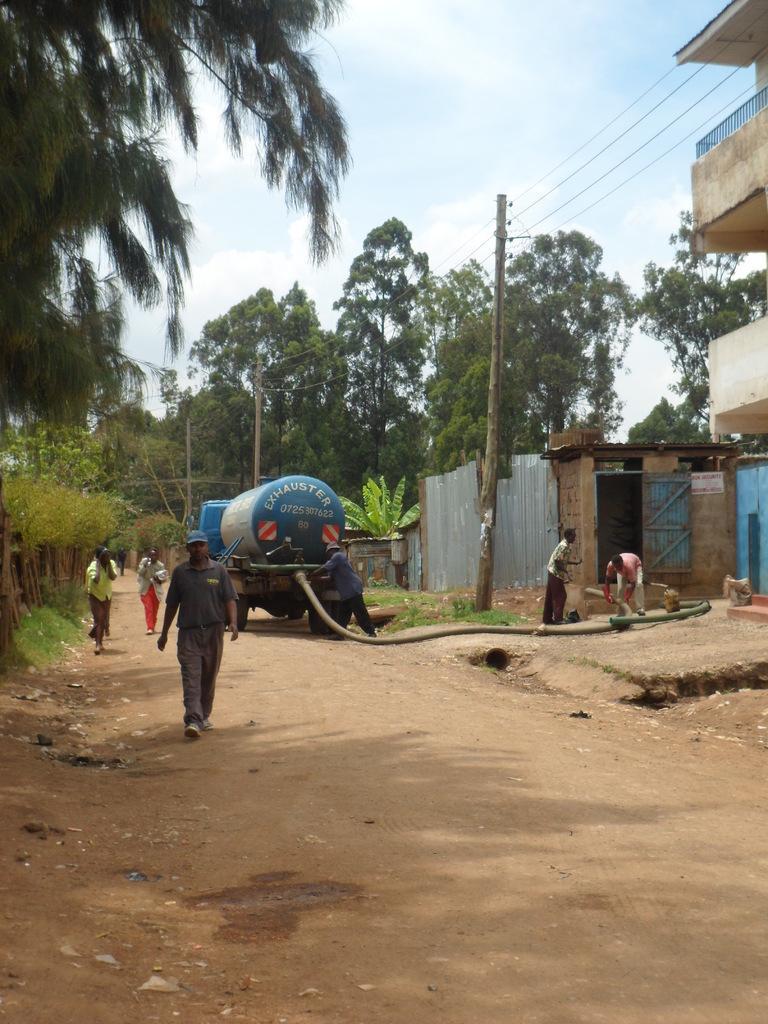Can you describe this image briefly? In the foreground of this image, there is a path and few persons are walking on it and there is also a tanker and a pipe attached to it. In the background, there are trees and poles. On the right, there is a building, pole and cables. On the top, there is the sky and the cloud. 